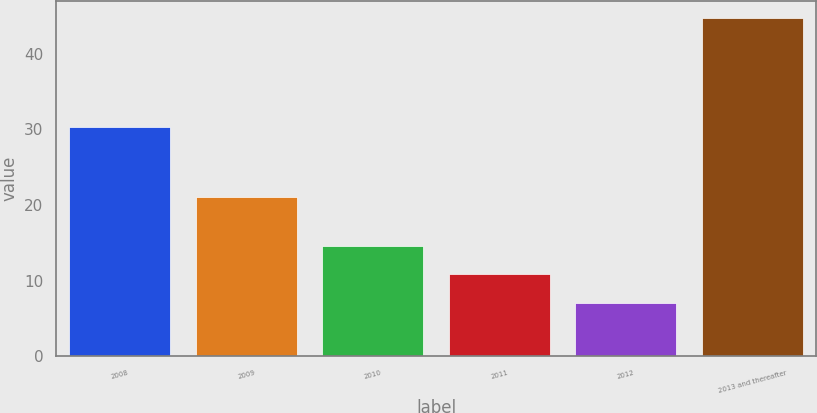<chart> <loc_0><loc_0><loc_500><loc_500><bar_chart><fcel>2008<fcel>2009<fcel>2010<fcel>2011<fcel>2012<fcel>2013 and thereafter<nl><fcel>30.3<fcel>21.1<fcel>14.62<fcel>10.86<fcel>7.1<fcel>44.7<nl></chart> 